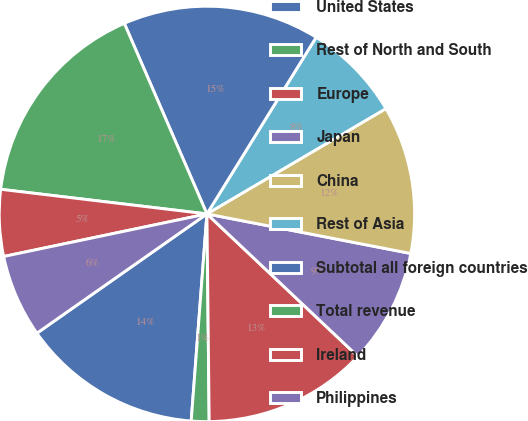Convert chart. <chart><loc_0><loc_0><loc_500><loc_500><pie_chart><fcel>United States<fcel>Rest of North and South<fcel>Europe<fcel>Japan<fcel>China<fcel>Rest of Asia<fcel>Subtotal all foreign countries<fcel>Total revenue<fcel>Ireland<fcel>Philippines<nl><fcel>14.06%<fcel>1.38%<fcel>12.79%<fcel>8.99%<fcel>11.52%<fcel>7.72%<fcel>15.33%<fcel>16.6%<fcel>5.18%<fcel>6.45%<nl></chart> 